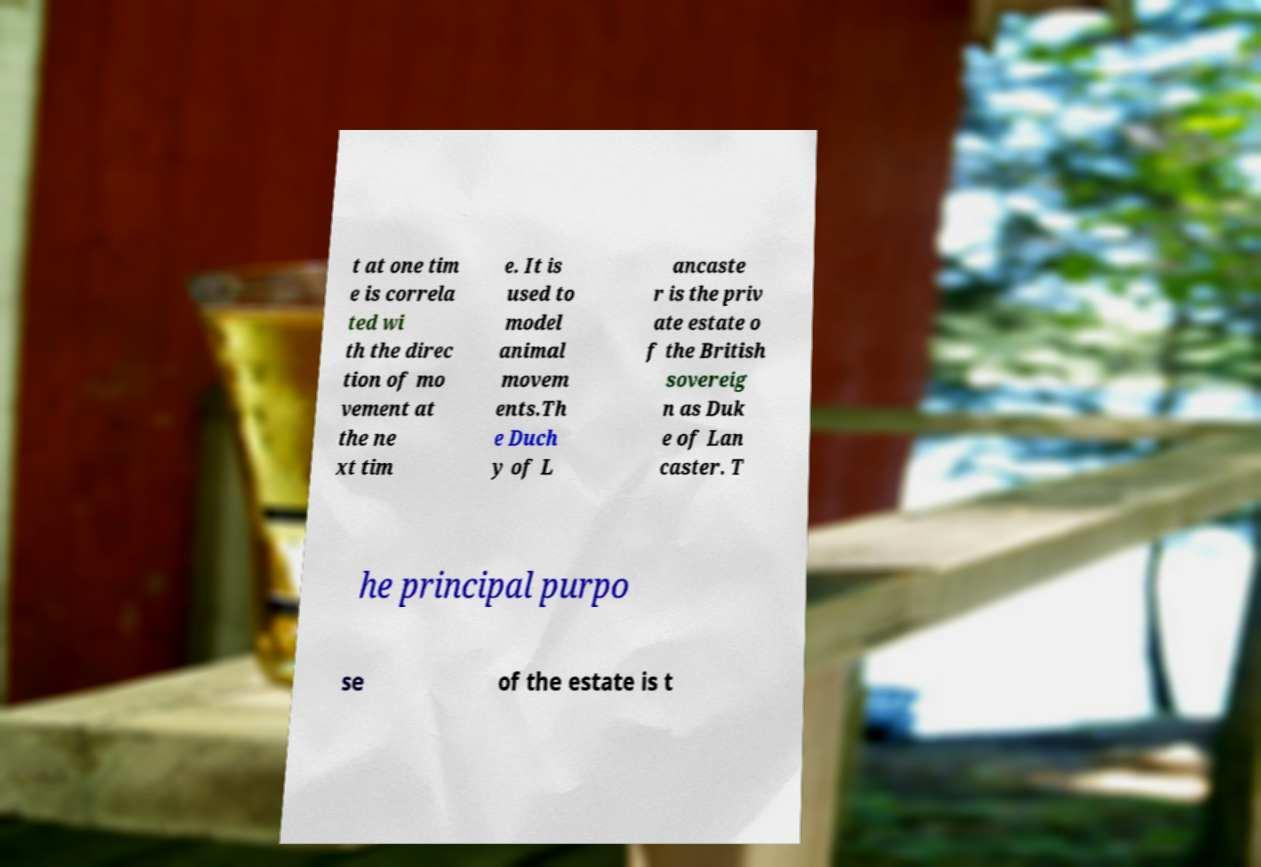There's text embedded in this image that I need extracted. Can you transcribe it verbatim? t at one tim e is correla ted wi th the direc tion of mo vement at the ne xt tim e. It is used to model animal movem ents.Th e Duch y of L ancaste r is the priv ate estate o f the British sovereig n as Duk e of Lan caster. T he principal purpo se of the estate is t 